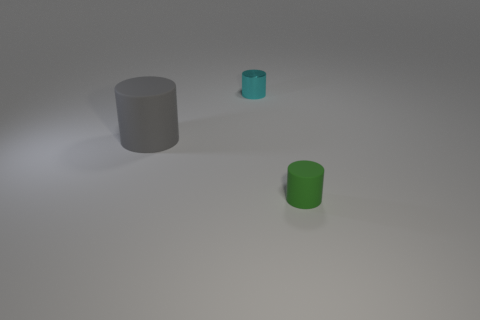There is a cylinder that is on the left side of the shiny object; how many tiny cylinders are left of it?
Offer a very short reply. 0. There is a green object that is to the right of the cyan metallic object; what shape is it?
Ensure brevity in your answer.  Cylinder. What is the material of the object that is right of the small cylinder that is left of the rubber cylinder that is right of the small cyan cylinder?
Offer a very short reply. Rubber. What number of other things are there of the same size as the gray cylinder?
Ensure brevity in your answer.  0. There is another big thing that is the same shape as the cyan metallic object; what material is it?
Ensure brevity in your answer.  Rubber. The metallic thing is what color?
Provide a succinct answer. Cyan. What color is the small shiny object that is left of the small object that is in front of the gray thing?
Keep it short and to the point. Cyan. Is the color of the big object the same as the tiny thing that is in front of the metal cylinder?
Your response must be concise. No. There is a thing that is behind the big gray rubber cylinder that is on the left side of the tiny shiny thing; how many tiny metallic objects are in front of it?
Your answer should be very brief. 0. There is a green cylinder; are there any big rubber cylinders right of it?
Provide a succinct answer. No. 